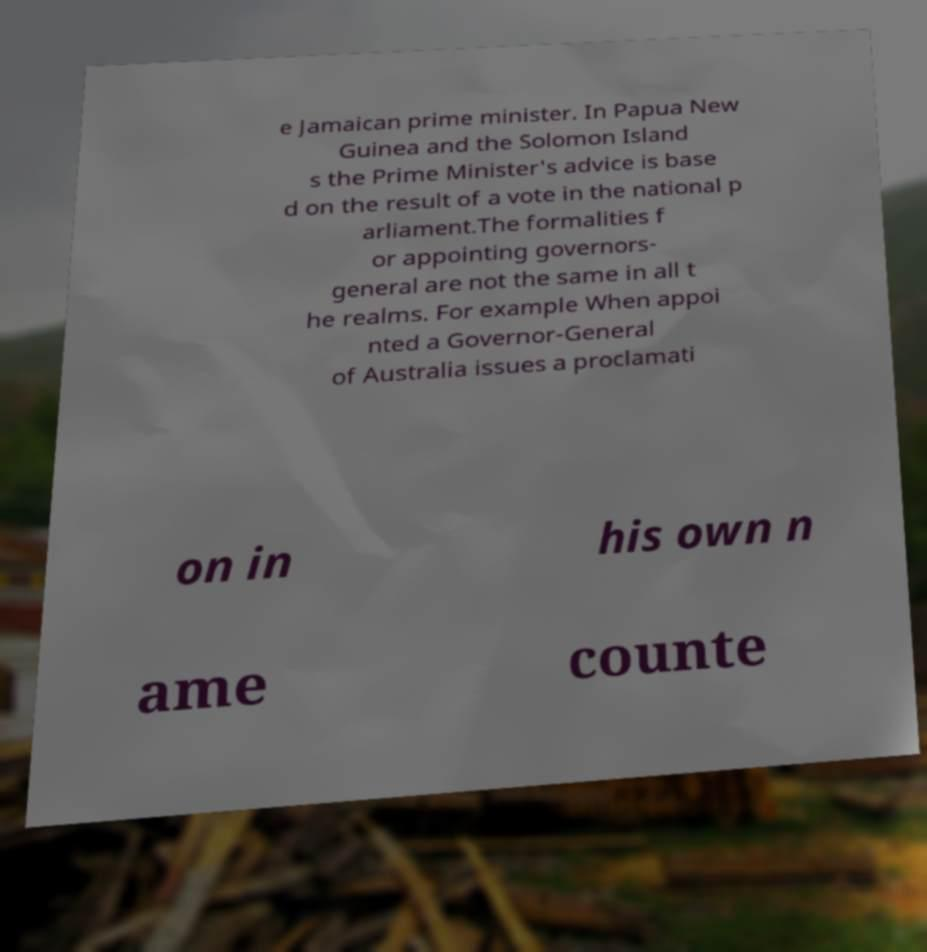Can you accurately transcribe the text from the provided image for me? e Jamaican prime minister. In Papua New Guinea and the Solomon Island s the Prime Minister's advice is base d on the result of a vote in the national p arliament.The formalities f or appointing governors- general are not the same in all t he realms. For example When appoi nted a Governor-General of Australia issues a proclamati on in his own n ame counte 